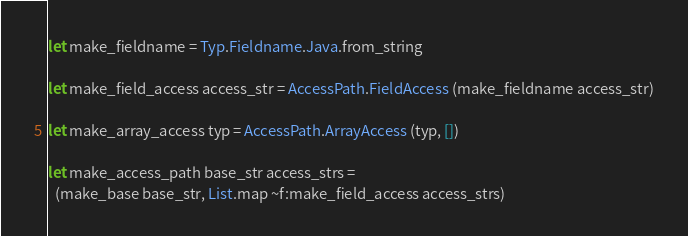<code> <loc_0><loc_0><loc_500><loc_500><_OCaml_>
let make_fieldname = Typ.Fieldname.Java.from_string

let make_field_access access_str = AccessPath.FieldAccess (make_fieldname access_str)

let make_array_access typ = AccessPath.ArrayAccess (typ, [])

let make_access_path base_str access_strs =
  (make_base base_str, List.map ~f:make_field_access access_strs)
</code> 